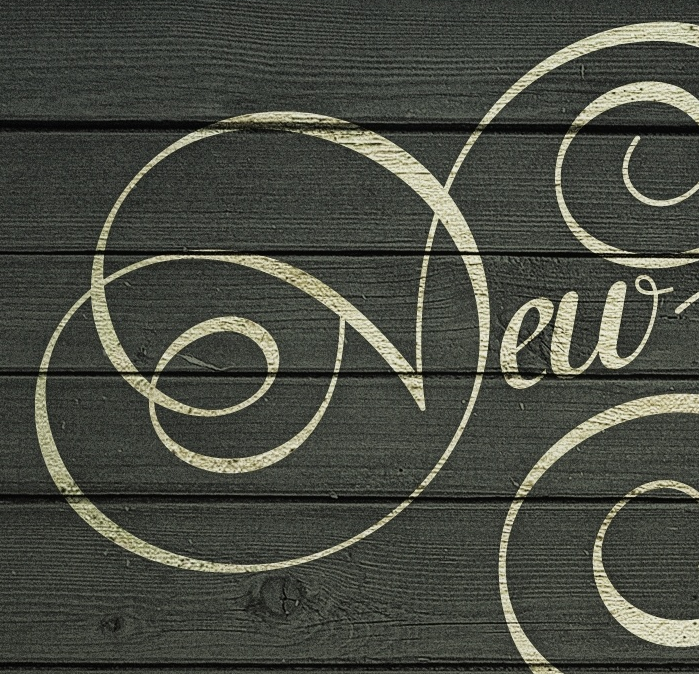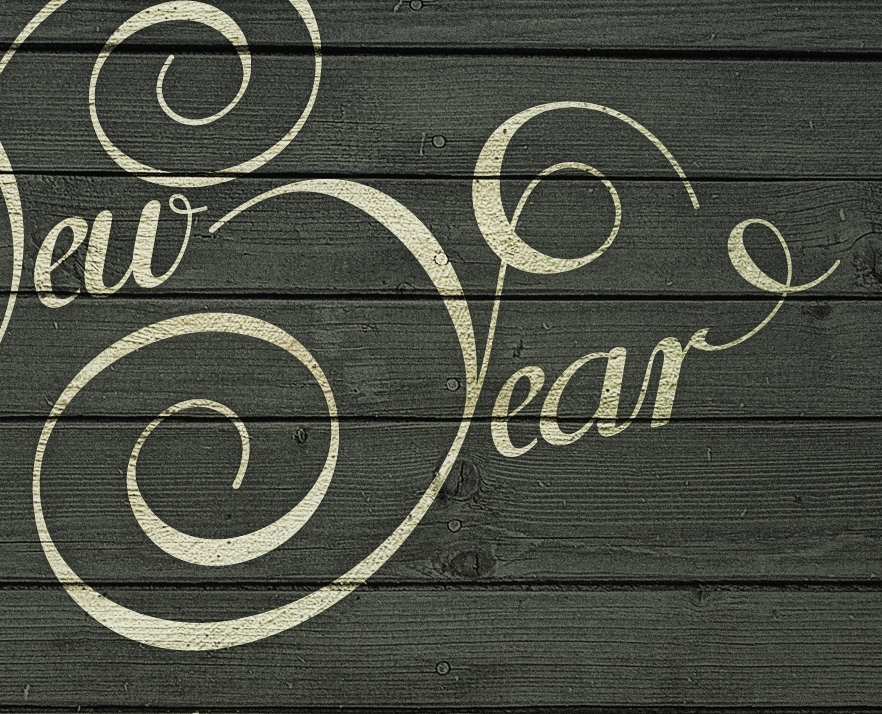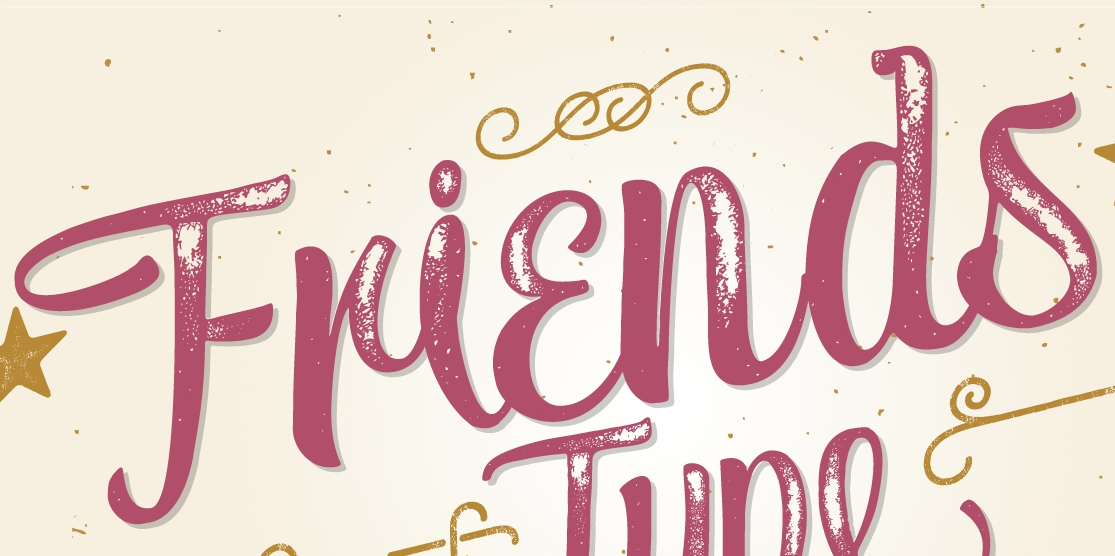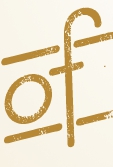Identify the words shown in these images in order, separated by a semicolon. New; Year; Friends; of 